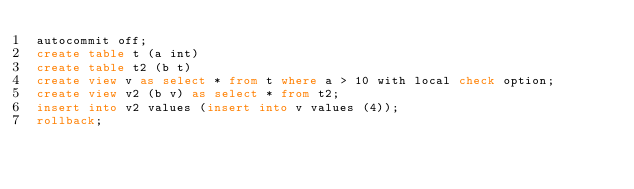<code> <loc_0><loc_0><loc_500><loc_500><_SQL_>autocommit off;
create table t (a int)
create table t2 (b t)
create view v as select * from t where a > 10 with local check option;
create view v2 (b v) as select * from t2;
insert into v2 values (insert into v values (4));
rollback;
</code> 